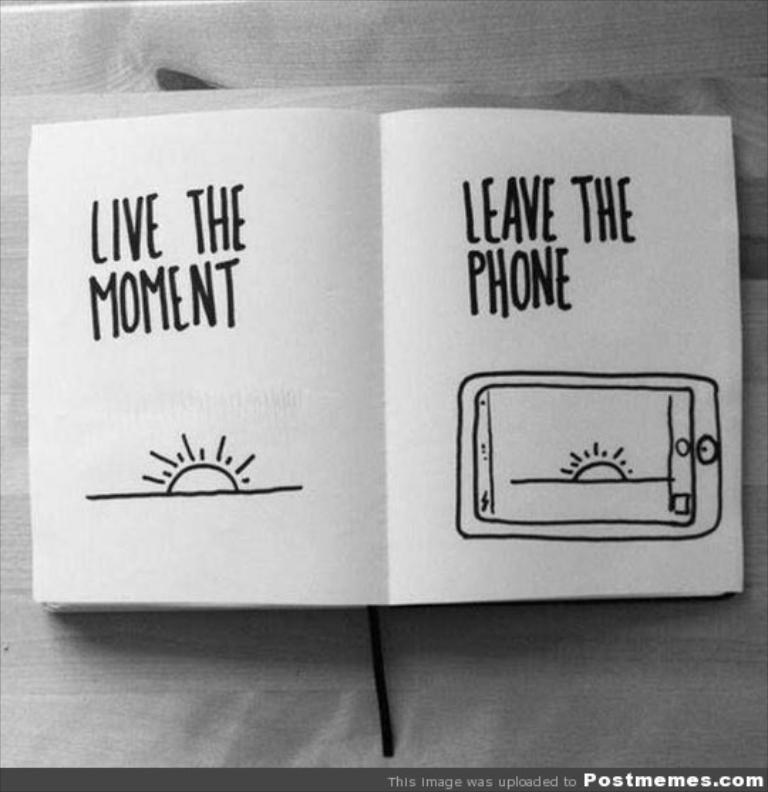<image>
Share a concise interpretation of the image provided. A book reads "LIVE THE MOMENT LEAVE THE PHONE." 